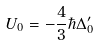Convert formula to latex. <formula><loc_0><loc_0><loc_500><loc_500>U _ { 0 } = - \frac { 4 } { 3 } \hbar { \Delta } _ { 0 } ^ { \prime }</formula> 